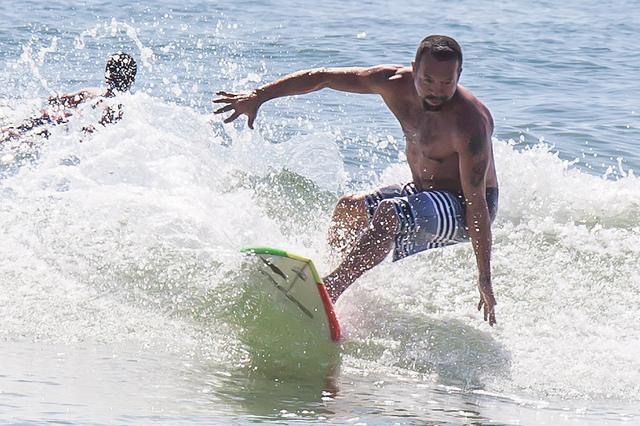What is the surfer doing to the wave? riding it 